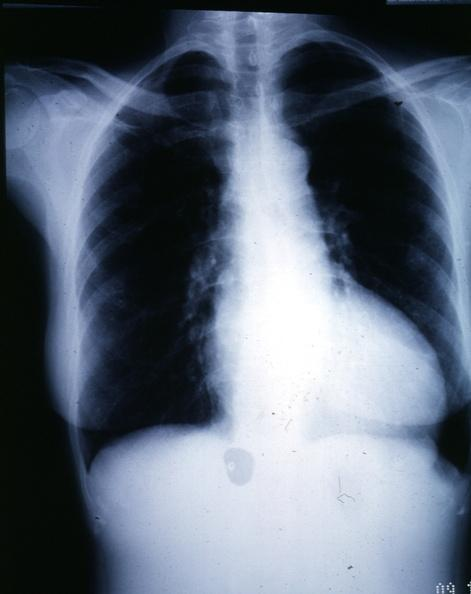what is present?
Answer the question using a single word or phrase. Left ventricle hypertrophy 